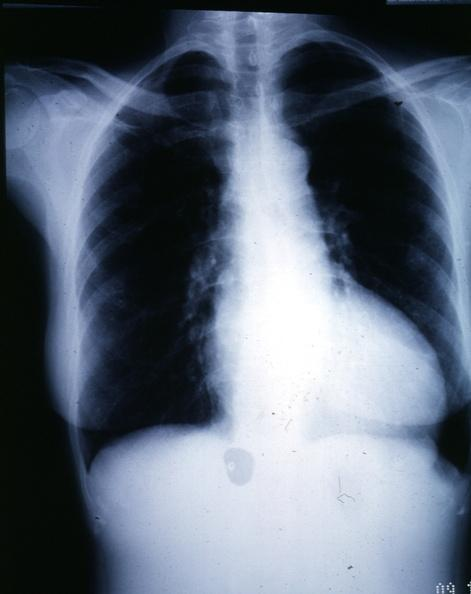what is present?
Answer the question using a single word or phrase. Left ventricle hypertrophy 